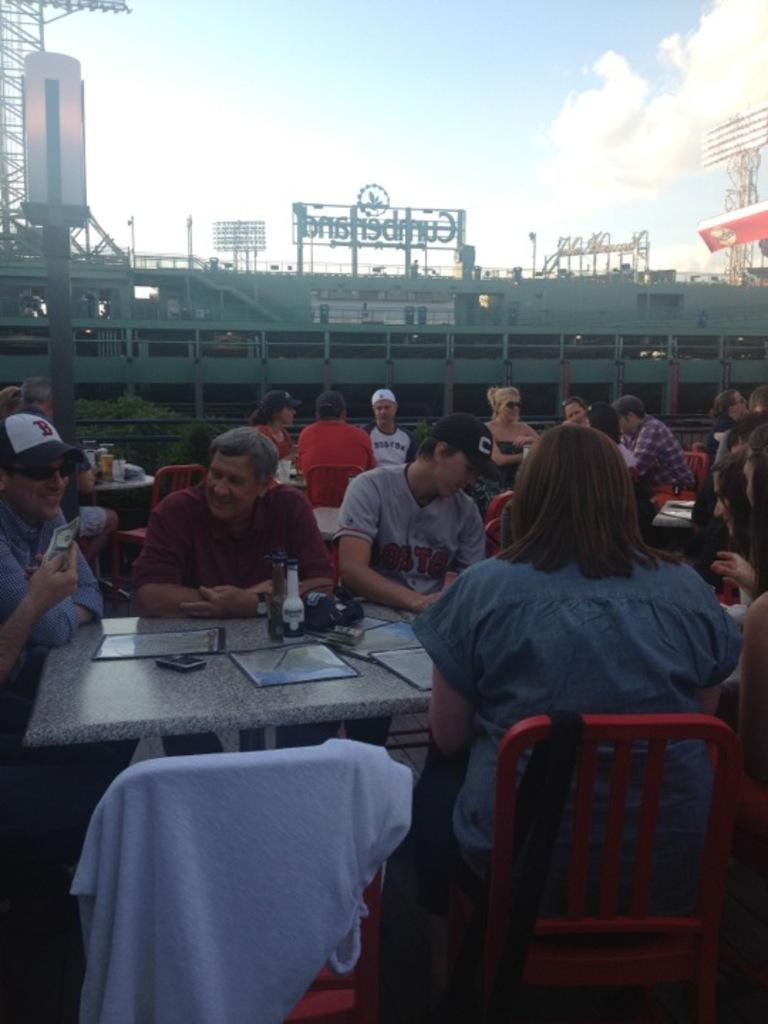What are the people in the image doing? The people in the image are sitting on chairs. What objects are in front of the people? There are tables in front of the people. What can be seen in the background of the image? The sky is visible in the background of the image. What type of thread is being used to create the list in the image? There is no list or thread present in the image. 